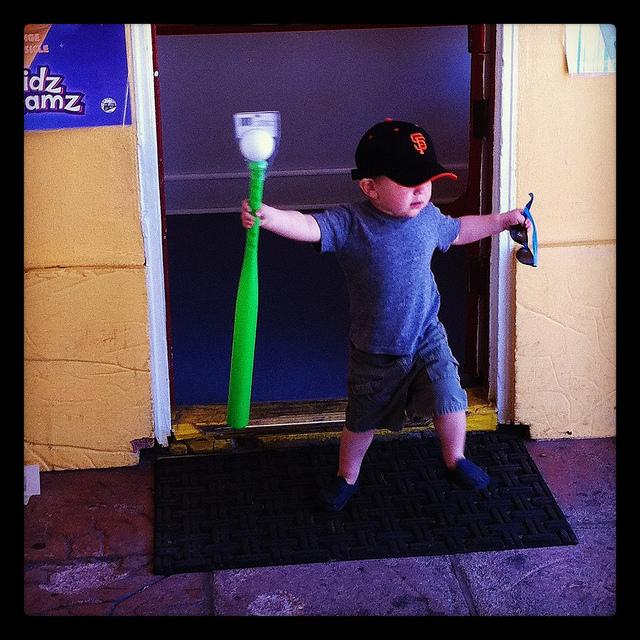What color is the bat the boy is holding?
Be succinct. Green. Is this a teenage boy?
Answer briefly. No. What is the boy holding in his left hand?
Answer briefly. Sunglasses. 